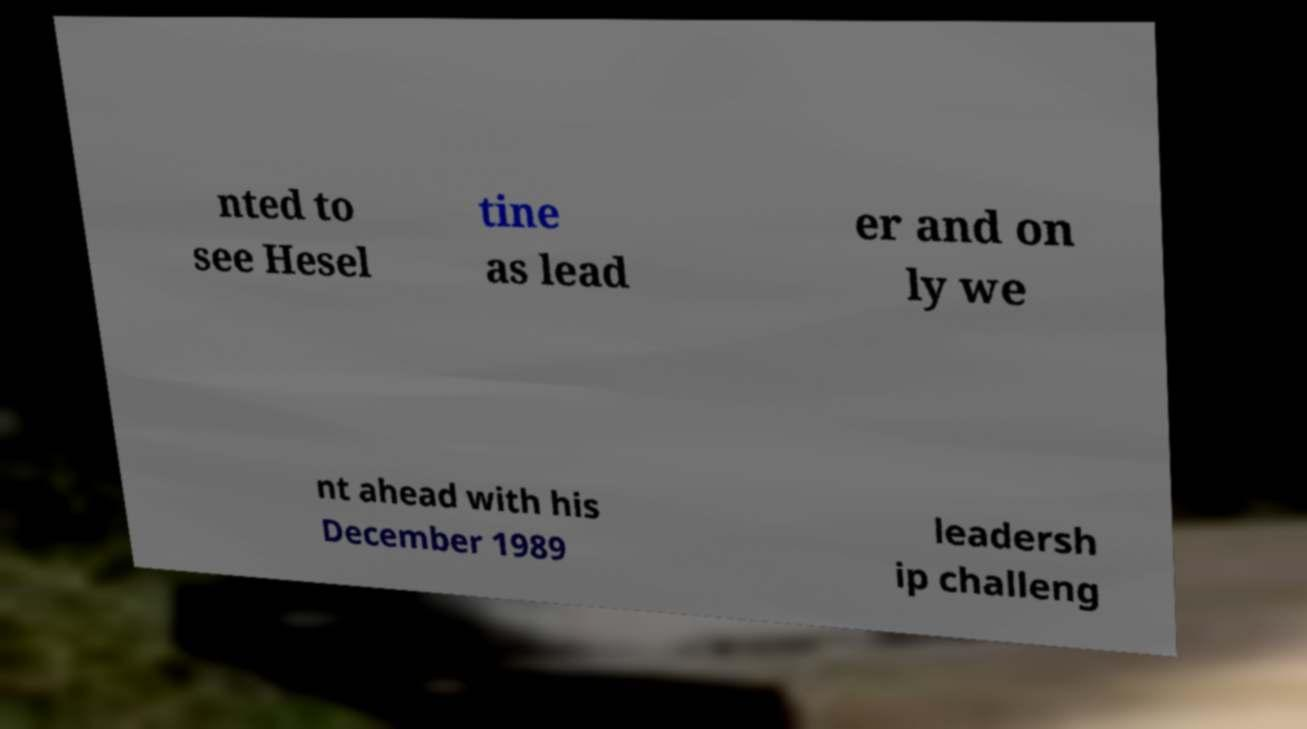Could you extract and type out the text from this image? nted to see Hesel tine as lead er and on ly we nt ahead with his December 1989 leadersh ip challeng 